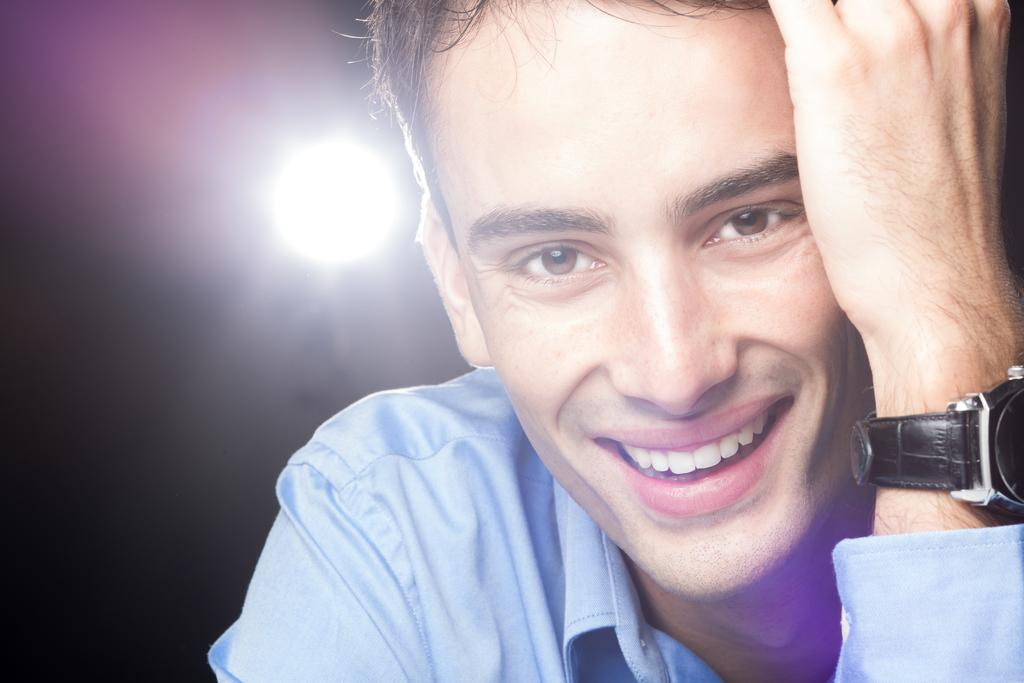What is the expression on the person's face in the image? The person is smiling in the image. What accessory can be seen on the person's hand? There is a watch on the person's hand. What can be seen in the background behind the person? There is a light visible behind the person. What idea does the person have for crushing the watch in the image? There is no indication in the image that the person has any intention of crushing the watch, and therefore no such idea can be inferred. 